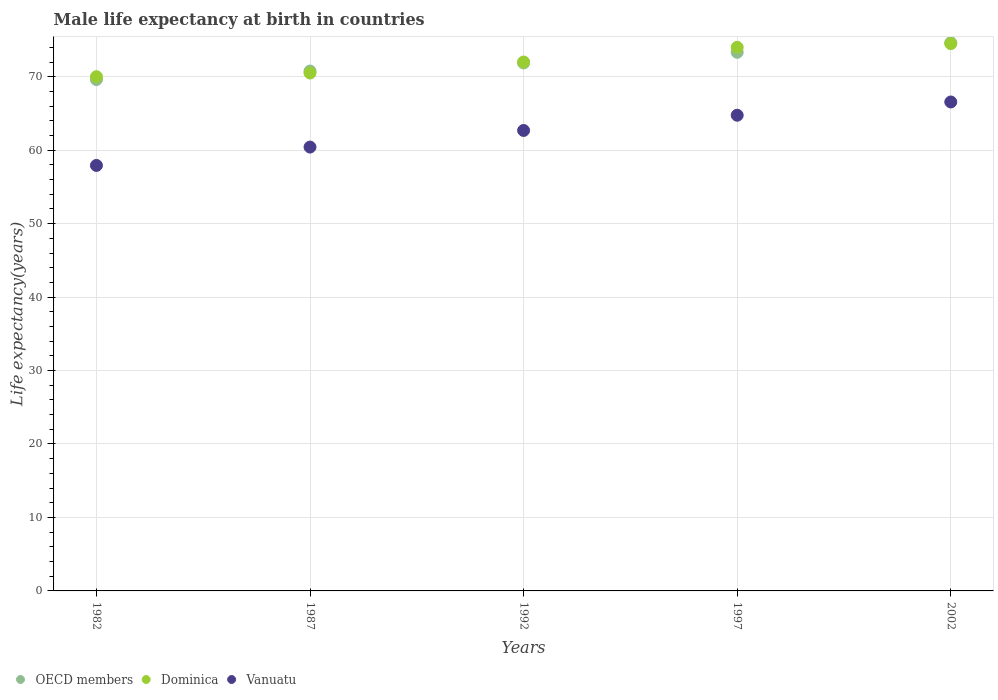How many different coloured dotlines are there?
Provide a short and direct response. 3. Is the number of dotlines equal to the number of legend labels?
Provide a short and direct response. Yes. What is the male life expectancy at birth in OECD members in 2002?
Provide a succinct answer. 74.63. Across all years, what is the maximum male life expectancy at birth in Vanuatu?
Provide a short and direct response. 66.56. Across all years, what is the minimum male life expectancy at birth in Vanuatu?
Your response must be concise. 57.92. In which year was the male life expectancy at birth in Dominica maximum?
Ensure brevity in your answer.  2002. What is the total male life expectancy at birth in Dominica in the graph?
Offer a terse response. 361. What is the difference between the male life expectancy at birth in Vanuatu in 1997 and that in 2002?
Your response must be concise. -1.8. What is the difference between the male life expectancy at birth in Vanuatu in 1992 and the male life expectancy at birth in Dominica in 1997?
Your answer should be very brief. -11.32. What is the average male life expectancy at birth in OECD members per year?
Your response must be concise. 72.04. In the year 1982, what is the difference between the male life expectancy at birth in Dominica and male life expectancy at birth in OECD members?
Give a very brief answer. 0.39. In how many years, is the male life expectancy at birth in Dominica greater than 52 years?
Provide a short and direct response. 5. What is the ratio of the male life expectancy at birth in Vanuatu in 1987 to that in 2002?
Offer a very short reply. 0.91. Is the male life expectancy at birth in Vanuatu in 1987 less than that in 2002?
Your answer should be compact. Yes. Is the difference between the male life expectancy at birth in Dominica in 1997 and 2002 greater than the difference between the male life expectancy at birth in OECD members in 1997 and 2002?
Your answer should be compact. Yes. What is the difference between the highest and the second highest male life expectancy at birth in OECD members?
Provide a succinct answer. 1.3. What is the difference between the highest and the lowest male life expectancy at birth in Dominica?
Ensure brevity in your answer.  4.5. In how many years, is the male life expectancy at birth in OECD members greater than the average male life expectancy at birth in OECD members taken over all years?
Make the answer very short. 2. Is the sum of the male life expectancy at birth in Dominica in 1982 and 1997 greater than the maximum male life expectancy at birth in OECD members across all years?
Make the answer very short. Yes. Is the male life expectancy at birth in Vanuatu strictly greater than the male life expectancy at birth in Dominica over the years?
Give a very brief answer. No. Is the male life expectancy at birth in OECD members strictly less than the male life expectancy at birth in Vanuatu over the years?
Your answer should be compact. No. What is the difference between two consecutive major ticks on the Y-axis?
Give a very brief answer. 10. Does the graph contain any zero values?
Your answer should be very brief. No. Does the graph contain grids?
Give a very brief answer. Yes. How are the legend labels stacked?
Provide a succinct answer. Horizontal. What is the title of the graph?
Provide a short and direct response. Male life expectancy at birth in countries. Does "Syrian Arab Republic" appear as one of the legend labels in the graph?
Ensure brevity in your answer.  No. What is the label or title of the X-axis?
Give a very brief answer. Years. What is the label or title of the Y-axis?
Provide a succinct answer. Life expectancy(years). What is the Life expectancy(years) in OECD members in 1982?
Keep it short and to the point. 69.61. What is the Life expectancy(years) of Dominica in 1982?
Your answer should be compact. 70. What is the Life expectancy(years) in Vanuatu in 1982?
Offer a terse response. 57.92. What is the Life expectancy(years) in OECD members in 1987?
Provide a short and direct response. 70.77. What is the Life expectancy(years) in Dominica in 1987?
Offer a very short reply. 70.5. What is the Life expectancy(years) of Vanuatu in 1987?
Offer a very short reply. 60.42. What is the Life expectancy(years) in OECD members in 1992?
Provide a short and direct response. 71.87. What is the Life expectancy(years) in Dominica in 1992?
Offer a very short reply. 72. What is the Life expectancy(years) in Vanuatu in 1992?
Offer a very short reply. 62.68. What is the Life expectancy(years) of OECD members in 1997?
Provide a succinct answer. 73.32. What is the Life expectancy(years) of Vanuatu in 1997?
Offer a very short reply. 64.75. What is the Life expectancy(years) of OECD members in 2002?
Your answer should be compact. 74.63. What is the Life expectancy(years) of Dominica in 2002?
Ensure brevity in your answer.  74.5. What is the Life expectancy(years) in Vanuatu in 2002?
Your answer should be compact. 66.56. Across all years, what is the maximum Life expectancy(years) of OECD members?
Your answer should be very brief. 74.63. Across all years, what is the maximum Life expectancy(years) of Dominica?
Give a very brief answer. 74.5. Across all years, what is the maximum Life expectancy(years) in Vanuatu?
Give a very brief answer. 66.56. Across all years, what is the minimum Life expectancy(years) of OECD members?
Keep it short and to the point. 69.61. Across all years, what is the minimum Life expectancy(years) of Dominica?
Make the answer very short. 70. Across all years, what is the minimum Life expectancy(years) of Vanuatu?
Keep it short and to the point. 57.92. What is the total Life expectancy(years) in OECD members in the graph?
Give a very brief answer. 360.2. What is the total Life expectancy(years) of Dominica in the graph?
Your answer should be compact. 361. What is the total Life expectancy(years) of Vanuatu in the graph?
Provide a succinct answer. 312.33. What is the difference between the Life expectancy(years) in OECD members in 1982 and that in 1987?
Ensure brevity in your answer.  -1.16. What is the difference between the Life expectancy(years) of OECD members in 1982 and that in 1992?
Make the answer very short. -2.26. What is the difference between the Life expectancy(years) in Dominica in 1982 and that in 1992?
Give a very brief answer. -2. What is the difference between the Life expectancy(years) of Vanuatu in 1982 and that in 1992?
Give a very brief answer. -4.76. What is the difference between the Life expectancy(years) in OECD members in 1982 and that in 1997?
Keep it short and to the point. -3.71. What is the difference between the Life expectancy(years) in Dominica in 1982 and that in 1997?
Offer a very short reply. -4. What is the difference between the Life expectancy(years) of Vanuatu in 1982 and that in 1997?
Offer a very short reply. -6.83. What is the difference between the Life expectancy(years) in OECD members in 1982 and that in 2002?
Ensure brevity in your answer.  -5.01. What is the difference between the Life expectancy(years) of Dominica in 1982 and that in 2002?
Provide a succinct answer. -4.5. What is the difference between the Life expectancy(years) of Vanuatu in 1982 and that in 2002?
Offer a very short reply. -8.64. What is the difference between the Life expectancy(years) of OECD members in 1987 and that in 1992?
Provide a short and direct response. -1.1. What is the difference between the Life expectancy(years) of Vanuatu in 1987 and that in 1992?
Offer a terse response. -2.26. What is the difference between the Life expectancy(years) in OECD members in 1987 and that in 1997?
Your response must be concise. -2.56. What is the difference between the Life expectancy(years) of Dominica in 1987 and that in 1997?
Make the answer very short. -3.5. What is the difference between the Life expectancy(years) in Vanuatu in 1987 and that in 1997?
Provide a short and direct response. -4.33. What is the difference between the Life expectancy(years) in OECD members in 1987 and that in 2002?
Make the answer very short. -3.86. What is the difference between the Life expectancy(years) of Vanuatu in 1987 and that in 2002?
Keep it short and to the point. -6.14. What is the difference between the Life expectancy(years) of OECD members in 1992 and that in 1997?
Provide a short and direct response. -1.45. What is the difference between the Life expectancy(years) of Dominica in 1992 and that in 1997?
Your answer should be very brief. -2. What is the difference between the Life expectancy(years) of Vanuatu in 1992 and that in 1997?
Your response must be concise. -2.07. What is the difference between the Life expectancy(years) in OECD members in 1992 and that in 2002?
Keep it short and to the point. -2.75. What is the difference between the Life expectancy(years) in Vanuatu in 1992 and that in 2002?
Give a very brief answer. -3.88. What is the difference between the Life expectancy(years) in OECD members in 1997 and that in 2002?
Ensure brevity in your answer.  -1.3. What is the difference between the Life expectancy(years) of Vanuatu in 1997 and that in 2002?
Keep it short and to the point. -1.8. What is the difference between the Life expectancy(years) of OECD members in 1982 and the Life expectancy(years) of Dominica in 1987?
Your answer should be very brief. -0.89. What is the difference between the Life expectancy(years) in OECD members in 1982 and the Life expectancy(years) in Vanuatu in 1987?
Provide a succinct answer. 9.19. What is the difference between the Life expectancy(years) in Dominica in 1982 and the Life expectancy(years) in Vanuatu in 1987?
Your answer should be very brief. 9.58. What is the difference between the Life expectancy(years) of OECD members in 1982 and the Life expectancy(years) of Dominica in 1992?
Offer a terse response. -2.39. What is the difference between the Life expectancy(years) in OECD members in 1982 and the Life expectancy(years) in Vanuatu in 1992?
Keep it short and to the point. 6.93. What is the difference between the Life expectancy(years) of Dominica in 1982 and the Life expectancy(years) of Vanuatu in 1992?
Offer a very short reply. 7.32. What is the difference between the Life expectancy(years) in OECD members in 1982 and the Life expectancy(years) in Dominica in 1997?
Make the answer very short. -4.39. What is the difference between the Life expectancy(years) in OECD members in 1982 and the Life expectancy(years) in Vanuatu in 1997?
Give a very brief answer. 4.86. What is the difference between the Life expectancy(years) in Dominica in 1982 and the Life expectancy(years) in Vanuatu in 1997?
Give a very brief answer. 5.25. What is the difference between the Life expectancy(years) of OECD members in 1982 and the Life expectancy(years) of Dominica in 2002?
Provide a short and direct response. -4.89. What is the difference between the Life expectancy(years) of OECD members in 1982 and the Life expectancy(years) of Vanuatu in 2002?
Your answer should be very brief. 3.05. What is the difference between the Life expectancy(years) of Dominica in 1982 and the Life expectancy(years) of Vanuatu in 2002?
Keep it short and to the point. 3.44. What is the difference between the Life expectancy(years) of OECD members in 1987 and the Life expectancy(years) of Dominica in 1992?
Your answer should be very brief. -1.23. What is the difference between the Life expectancy(years) in OECD members in 1987 and the Life expectancy(years) in Vanuatu in 1992?
Make the answer very short. 8.09. What is the difference between the Life expectancy(years) of Dominica in 1987 and the Life expectancy(years) of Vanuatu in 1992?
Your answer should be compact. 7.82. What is the difference between the Life expectancy(years) in OECD members in 1987 and the Life expectancy(years) in Dominica in 1997?
Your answer should be compact. -3.23. What is the difference between the Life expectancy(years) of OECD members in 1987 and the Life expectancy(years) of Vanuatu in 1997?
Ensure brevity in your answer.  6.01. What is the difference between the Life expectancy(years) in Dominica in 1987 and the Life expectancy(years) in Vanuatu in 1997?
Your response must be concise. 5.75. What is the difference between the Life expectancy(years) of OECD members in 1987 and the Life expectancy(years) of Dominica in 2002?
Give a very brief answer. -3.73. What is the difference between the Life expectancy(years) of OECD members in 1987 and the Life expectancy(years) of Vanuatu in 2002?
Ensure brevity in your answer.  4.21. What is the difference between the Life expectancy(years) in Dominica in 1987 and the Life expectancy(years) in Vanuatu in 2002?
Your response must be concise. 3.94. What is the difference between the Life expectancy(years) of OECD members in 1992 and the Life expectancy(years) of Dominica in 1997?
Give a very brief answer. -2.13. What is the difference between the Life expectancy(years) of OECD members in 1992 and the Life expectancy(years) of Vanuatu in 1997?
Make the answer very short. 7.12. What is the difference between the Life expectancy(years) of Dominica in 1992 and the Life expectancy(years) of Vanuatu in 1997?
Offer a very short reply. 7.25. What is the difference between the Life expectancy(years) of OECD members in 1992 and the Life expectancy(years) of Dominica in 2002?
Your response must be concise. -2.63. What is the difference between the Life expectancy(years) of OECD members in 1992 and the Life expectancy(years) of Vanuatu in 2002?
Your response must be concise. 5.31. What is the difference between the Life expectancy(years) in Dominica in 1992 and the Life expectancy(years) in Vanuatu in 2002?
Provide a short and direct response. 5.44. What is the difference between the Life expectancy(years) of OECD members in 1997 and the Life expectancy(years) of Dominica in 2002?
Offer a terse response. -1.18. What is the difference between the Life expectancy(years) in OECD members in 1997 and the Life expectancy(years) in Vanuatu in 2002?
Your answer should be compact. 6.77. What is the difference between the Life expectancy(years) of Dominica in 1997 and the Life expectancy(years) of Vanuatu in 2002?
Your answer should be compact. 7.44. What is the average Life expectancy(years) of OECD members per year?
Your answer should be compact. 72.04. What is the average Life expectancy(years) in Dominica per year?
Ensure brevity in your answer.  72.2. What is the average Life expectancy(years) in Vanuatu per year?
Provide a succinct answer. 62.47. In the year 1982, what is the difference between the Life expectancy(years) of OECD members and Life expectancy(years) of Dominica?
Offer a terse response. -0.39. In the year 1982, what is the difference between the Life expectancy(years) of OECD members and Life expectancy(years) of Vanuatu?
Provide a succinct answer. 11.69. In the year 1982, what is the difference between the Life expectancy(years) in Dominica and Life expectancy(years) in Vanuatu?
Your answer should be very brief. 12.08. In the year 1987, what is the difference between the Life expectancy(years) in OECD members and Life expectancy(years) in Dominica?
Offer a very short reply. 0.27. In the year 1987, what is the difference between the Life expectancy(years) of OECD members and Life expectancy(years) of Vanuatu?
Your response must be concise. 10.35. In the year 1987, what is the difference between the Life expectancy(years) of Dominica and Life expectancy(years) of Vanuatu?
Provide a succinct answer. 10.08. In the year 1992, what is the difference between the Life expectancy(years) in OECD members and Life expectancy(years) in Dominica?
Offer a terse response. -0.13. In the year 1992, what is the difference between the Life expectancy(years) of OECD members and Life expectancy(years) of Vanuatu?
Give a very brief answer. 9.19. In the year 1992, what is the difference between the Life expectancy(years) in Dominica and Life expectancy(years) in Vanuatu?
Your response must be concise. 9.32. In the year 1997, what is the difference between the Life expectancy(years) in OECD members and Life expectancy(years) in Dominica?
Give a very brief answer. -0.68. In the year 1997, what is the difference between the Life expectancy(years) in OECD members and Life expectancy(years) in Vanuatu?
Give a very brief answer. 8.57. In the year 1997, what is the difference between the Life expectancy(years) of Dominica and Life expectancy(years) of Vanuatu?
Make the answer very short. 9.25. In the year 2002, what is the difference between the Life expectancy(years) in OECD members and Life expectancy(years) in Dominica?
Ensure brevity in your answer.  0.13. In the year 2002, what is the difference between the Life expectancy(years) in OECD members and Life expectancy(years) in Vanuatu?
Provide a short and direct response. 8.07. In the year 2002, what is the difference between the Life expectancy(years) in Dominica and Life expectancy(years) in Vanuatu?
Provide a short and direct response. 7.94. What is the ratio of the Life expectancy(years) of OECD members in 1982 to that in 1987?
Ensure brevity in your answer.  0.98. What is the ratio of the Life expectancy(years) of Dominica in 1982 to that in 1987?
Provide a short and direct response. 0.99. What is the ratio of the Life expectancy(years) in Vanuatu in 1982 to that in 1987?
Your answer should be very brief. 0.96. What is the ratio of the Life expectancy(years) in OECD members in 1982 to that in 1992?
Provide a short and direct response. 0.97. What is the ratio of the Life expectancy(years) of Dominica in 1982 to that in 1992?
Ensure brevity in your answer.  0.97. What is the ratio of the Life expectancy(years) of Vanuatu in 1982 to that in 1992?
Provide a succinct answer. 0.92. What is the ratio of the Life expectancy(years) of OECD members in 1982 to that in 1997?
Provide a short and direct response. 0.95. What is the ratio of the Life expectancy(years) of Dominica in 1982 to that in 1997?
Offer a very short reply. 0.95. What is the ratio of the Life expectancy(years) in Vanuatu in 1982 to that in 1997?
Your response must be concise. 0.89. What is the ratio of the Life expectancy(years) in OECD members in 1982 to that in 2002?
Offer a terse response. 0.93. What is the ratio of the Life expectancy(years) of Dominica in 1982 to that in 2002?
Your answer should be very brief. 0.94. What is the ratio of the Life expectancy(years) in Vanuatu in 1982 to that in 2002?
Your answer should be compact. 0.87. What is the ratio of the Life expectancy(years) of OECD members in 1987 to that in 1992?
Keep it short and to the point. 0.98. What is the ratio of the Life expectancy(years) in Dominica in 1987 to that in 1992?
Your answer should be compact. 0.98. What is the ratio of the Life expectancy(years) in Vanuatu in 1987 to that in 1992?
Offer a terse response. 0.96. What is the ratio of the Life expectancy(years) of OECD members in 1987 to that in 1997?
Make the answer very short. 0.97. What is the ratio of the Life expectancy(years) of Dominica in 1987 to that in 1997?
Provide a short and direct response. 0.95. What is the ratio of the Life expectancy(years) of Vanuatu in 1987 to that in 1997?
Your answer should be very brief. 0.93. What is the ratio of the Life expectancy(years) of OECD members in 1987 to that in 2002?
Provide a succinct answer. 0.95. What is the ratio of the Life expectancy(years) of Dominica in 1987 to that in 2002?
Your answer should be very brief. 0.95. What is the ratio of the Life expectancy(years) in Vanuatu in 1987 to that in 2002?
Make the answer very short. 0.91. What is the ratio of the Life expectancy(years) in OECD members in 1992 to that in 1997?
Give a very brief answer. 0.98. What is the ratio of the Life expectancy(years) in OECD members in 1992 to that in 2002?
Offer a very short reply. 0.96. What is the ratio of the Life expectancy(years) of Dominica in 1992 to that in 2002?
Your answer should be very brief. 0.97. What is the ratio of the Life expectancy(years) in Vanuatu in 1992 to that in 2002?
Keep it short and to the point. 0.94. What is the ratio of the Life expectancy(years) in OECD members in 1997 to that in 2002?
Make the answer very short. 0.98. What is the ratio of the Life expectancy(years) in Dominica in 1997 to that in 2002?
Give a very brief answer. 0.99. What is the ratio of the Life expectancy(years) in Vanuatu in 1997 to that in 2002?
Ensure brevity in your answer.  0.97. What is the difference between the highest and the second highest Life expectancy(years) of OECD members?
Your response must be concise. 1.3. What is the difference between the highest and the second highest Life expectancy(years) of Vanuatu?
Give a very brief answer. 1.8. What is the difference between the highest and the lowest Life expectancy(years) in OECD members?
Keep it short and to the point. 5.01. What is the difference between the highest and the lowest Life expectancy(years) in Dominica?
Keep it short and to the point. 4.5. What is the difference between the highest and the lowest Life expectancy(years) in Vanuatu?
Your answer should be very brief. 8.64. 